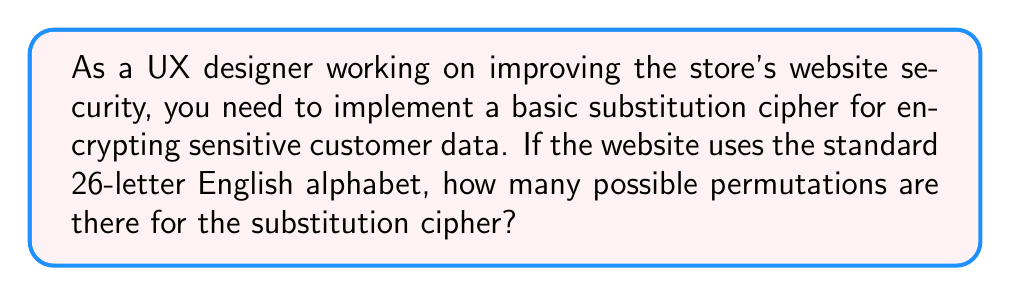Provide a solution to this math problem. Let's approach this step-by-step:

1. In a substitution cipher, each letter of the alphabet is replaced by another letter.

2. For the first letter, we have 26 choices.

3. For the second letter, we have 25 choices (because one letter has already been used).

4. For the third letter, we have 24 choices, and so on.

5. This pattern continues until we reach the last letter, for which we have only 1 choice.

6. Mathematically, this is represented by the factorial of 26, written as 26!

7. The formula for this is:

   $$26! = 26 \times 25 \times 24 \times ... \times 3 \times 2 \times 1$$

8. Calculating this:
   $$26! = 403,291,461,126,605,635,584,000,000$$

This large number represents the total number of possible permutations for a substitution cipher using a 26-letter alphabet.
Answer: $26! = 403,291,461,126,605,635,584,000,000$ 